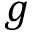<formula> <loc_0><loc_0><loc_500><loc_500>g</formula> 